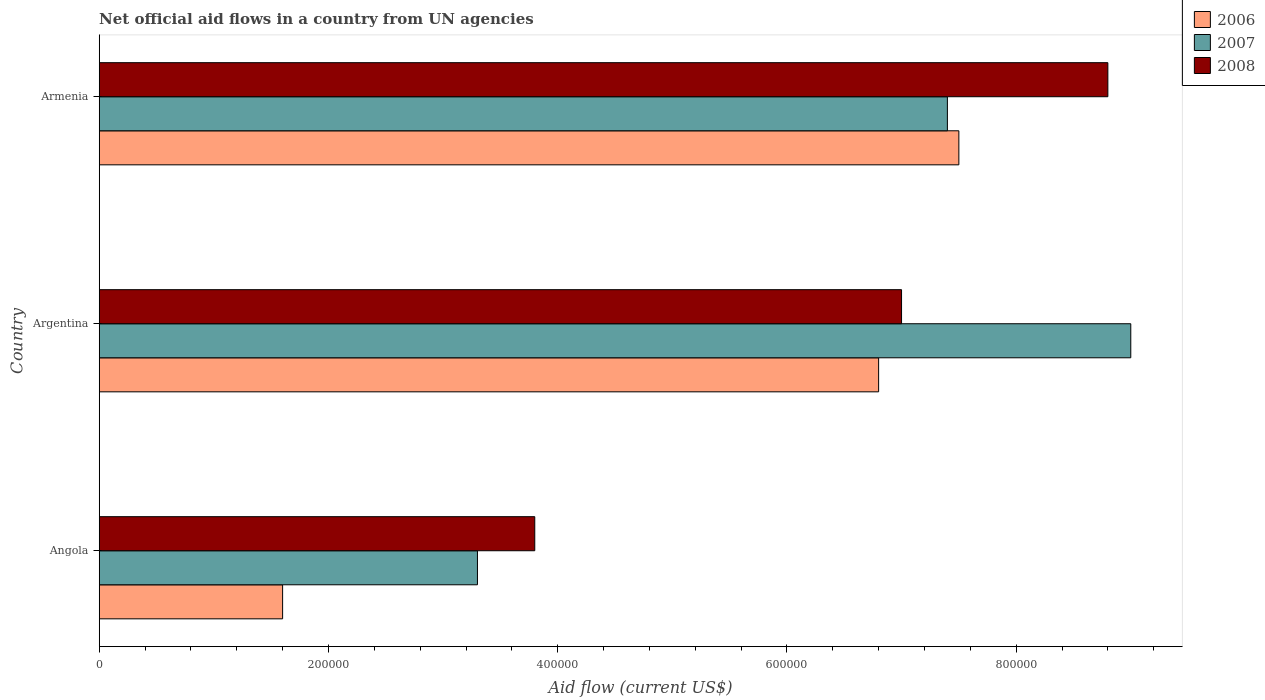How many bars are there on the 1st tick from the top?
Provide a short and direct response. 3. How many bars are there on the 1st tick from the bottom?
Your answer should be very brief. 3. In how many cases, is the number of bars for a given country not equal to the number of legend labels?
Your answer should be compact. 0. Across all countries, what is the maximum net official aid flow in 2008?
Ensure brevity in your answer.  8.80e+05. In which country was the net official aid flow in 2006 maximum?
Provide a short and direct response. Armenia. In which country was the net official aid flow in 2006 minimum?
Keep it short and to the point. Angola. What is the total net official aid flow in 2006 in the graph?
Your response must be concise. 1.59e+06. What is the difference between the net official aid flow in 2008 in Angola and that in Argentina?
Offer a very short reply. -3.20e+05. What is the difference between the net official aid flow in 2008 in Argentina and the net official aid flow in 2007 in Angola?
Make the answer very short. 3.70e+05. What is the average net official aid flow in 2007 per country?
Keep it short and to the point. 6.57e+05. What is the ratio of the net official aid flow in 2006 in Angola to that in Argentina?
Keep it short and to the point. 0.24. Is the net official aid flow in 2006 in Angola less than that in Armenia?
Provide a short and direct response. Yes. Is the difference between the net official aid flow in 2007 in Angola and Argentina greater than the difference between the net official aid flow in 2008 in Angola and Argentina?
Your response must be concise. No. What is the difference between the highest and the second highest net official aid flow in 2008?
Make the answer very short. 1.80e+05. In how many countries, is the net official aid flow in 2006 greater than the average net official aid flow in 2006 taken over all countries?
Offer a very short reply. 2. Is the sum of the net official aid flow in 2006 in Argentina and Armenia greater than the maximum net official aid flow in 2008 across all countries?
Provide a short and direct response. Yes. What does the 2nd bar from the bottom in Angola represents?
Keep it short and to the point. 2007. How many bars are there?
Make the answer very short. 9. Are all the bars in the graph horizontal?
Offer a terse response. Yes. What is the difference between two consecutive major ticks on the X-axis?
Keep it short and to the point. 2.00e+05. Are the values on the major ticks of X-axis written in scientific E-notation?
Provide a short and direct response. No. Where does the legend appear in the graph?
Make the answer very short. Top right. What is the title of the graph?
Your answer should be very brief. Net official aid flows in a country from UN agencies. What is the label or title of the X-axis?
Provide a succinct answer. Aid flow (current US$). What is the Aid flow (current US$) in 2006 in Angola?
Provide a short and direct response. 1.60e+05. What is the Aid flow (current US$) of 2007 in Angola?
Make the answer very short. 3.30e+05. What is the Aid flow (current US$) of 2006 in Argentina?
Your response must be concise. 6.80e+05. What is the Aid flow (current US$) of 2006 in Armenia?
Provide a short and direct response. 7.50e+05. What is the Aid flow (current US$) of 2007 in Armenia?
Keep it short and to the point. 7.40e+05. What is the Aid flow (current US$) of 2008 in Armenia?
Offer a terse response. 8.80e+05. Across all countries, what is the maximum Aid flow (current US$) of 2006?
Provide a succinct answer. 7.50e+05. Across all countries, what is the maximum Aid flow (current US$) of 2007?
Your response must be concise. 9.00e+05. Across all countries, what is the maximum Aid flow (current US$) in 2008?
Give a very brief answer. 8.80e+05. Across all countries, what is the minimum Aid flow (current US$) of 2006?
Provide a succinct answer. 1.60e+05. Across all countries, what is the minimum Aid flow (current US$) of 2007?
Keep it short and to the point. 3.30e+05. Across all countries, what is the minimum Aid flow (current US$) in 2008?
Your answer should be compact. 3.80e+05. What is the total Aid flow (current US$) of 2006 in the graph?
Give a very brief answer. 1.59e+06. What is the total Aid flow (current US$) in 2007 in the graph?
Provide a succinct answer. 1.97e+06. What is the total Aid flow (current US$) in 2008 in the graph?
Ensure brevity in your answer.  1.96e+06. What is the difference between the Aid flow (current US$) in 2006 in Angola and that in Argentina?
Your answer should be very brief. -5.20e+05. What is the difference between the Aid flow (current US$) of 2007 in Angola and that in Argentina?
Offer a terse response. -5.70e+05. What is the difference between the Aid flow (current US$) in 2008 in Angola and that in Argentina?
Keep it short and to the point. -3.20e+05. What is the difference between the Aid flow (current US$) in 2006 in Angola and that in Armenia?
Ensure brevity in your answer.  -5.90e+05. What is the difference between the Aid flow (current US$) in 2007 in Angola and that in Armenia?
Your answer should be compact. -4.10e+05. What is the difference between the Aid flow (current US$) of 2008 in Angola and that in Armenia?
Offer a terse response. -5.00e+05. What is the difference between the Aid flow (current US$) in 2006 in Argentina and that in Armenia?
Provide a short and direct response. -7.00e+04. What is the difference between the Aid flow (current US$) of 2007 in Argentina and that in Armenia?
Provide a short and direct response. 1.60e+05. What is the difference between the Aid flow (current US$) of 2008 in Argentina and that in Armenia?
Offer a terse response. -1.80e+05. What is the difference between the Aid flow (current US$) of 2006 in Angola and the Aid flow (current US$) of 2007 in Argentina?
Provide a succinct answer. -7.40e+05. What is the difference between the Aid flow (current US$) of 2006 in Angola and the Aid flow (current US$) of 2008 in Argentina?
Your answer should be compact. -5.40e+05. What is the difference between the Aid flow (current US$) of 2007 in Angola and the Aid flow (current US$) of 2008 in Argentina?
Offer a very short reply. -3.70e+05. What is the difference between the Aid flow (current US$) in 2006 in Angola and the Aid flow (current US$) in 2007 in Armenia?
Provide a short and direct response. -5.80e+05. What is the difference between the Aid flow (current US$) in 2006 in Angola and the Aid flow (current US$) in 2008 in Armenia?
Give a very brief answer. -7.20e+05. What is the difference between the Aid flow (current US$) in 2007 in Angola and the Aid flow (current US$) in 2008 in Armenia?
Keep it short and to the point. -5.50e+05. What is the difference between the Aid flow (current US$) of 2007 in Argentina and the Aid flow (current US$) of 2008 in Armenia?
Your response must be concise. 2.00e+04. What is the average Aid flow (current US$) in 2006 per country?
Your answer should be very brief. 5.30e+05. What is the average Aid flow (current US$) in 2007 per country?
Offer a very short reply. 6.57e+05. What is the average Aid flow (current US$) in 2008 per country?
Offer a very short reply. 6.53e+05. What is the difference between the Aid flow (current US$) in 2006 and Aid flow (current US$) in 2008 in Angola?
Offer a terse response. -2.20e+05. What is the difference between the Aid flow (current US$) in 2006 and Aid flow (current US$) in 2007 in Armenia?
Ensure brevity in your answer.  10000. What is the difference between the Aid flow (current US$) in 2007 and Aid flow (current US$) in 2008 in Armenia?
Keep it short and to the point. -1.40e+05. What is the ratio of the Aid flow (current US$) in 2006 in Angola to that in Argentina?
Your response must be concise. 0.24. What is the ratio of the Aid flow (current US$) in 2007 in Angola to that in Argentina?
Keep it short and to the point. 0.37. What is the ratio of the Aid flow (current US$) in 2008 in Angola to that in Argentina?
Provide a short and direct response. 0.54. What is the ratio of the Aid flow (current US$) of 2006 in Angola to that in Armenia?
Make the answer very short. 0.21. What is the ratio of the Aid flow (current US$) in 2007 in Angola to that in Armenia?
Offer a terse response. 0.45. What is the ratio of the Aid flow (current US$) in 2008 in Angola to that in Armenia?
Provide a short and direct response. 0.43. What is the ratio of the Aid flow (current US$) of 2006 in Argentina to that in Armenia?
Your answer should be compact. 0.91. What is the ratio of the Aid flow (current US$) in 2007 in Argentina to that in Armenia?
Provide a succinct answer. 1.22. What is the ratio of the Aid flow (current US$) in 2008 in Argentina to that in Armenia?
Offer a very short reply. 0.8. What is the difference between the highest and the second highest Aid flow (current US$) of 2006?
Your answer should be very brief. 7.00e+04. What is the difference between the highest and the second highest Aid flow (current US$) of 2008?
Provide a short and direct response. 1.80e+05. What is the difference between the highest and the lowest Aid flow (current US$) in 2006?
Provide a short and direct response. 5.90e+05. What is the difference between the highest and the lowest Aid flow (current US$) in 2007?
Provide a succinct answer. 5.70e+05. What is the difference between the highest and the lowest Aid flow (current US$) in 2008?
Provide a short and direct response. 5.00e+05. 